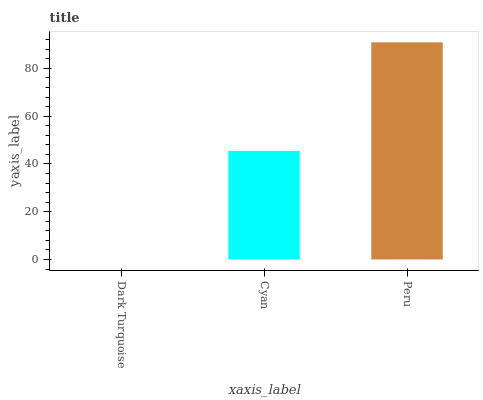Is Dark Turquoise the minimum?
Answer yes or no. Yes. Is Peru the maximum?
Answer yes or no. Yes. Is Cyan the minimum?
Answer yes or no. No. Is Cyan the maximum?
Answer yes or no. No. Is Cyan greater than Dark Turquoise?
Answer yes or no. Yes. Is Dark Turquoise less than Cyan?
Answer yes or no. Yes. Is Dark Turquoise greater than Cyan?
Answer yes or no. No. Is Cyan less than Dark Turquoise?
Answer yes or no. No. Is Cyan the high median?
Answer yes or no. Yes. Is Cyan the low median?
Answer yes or no. Yes. Is Dark Turquoise the high median?
Answer yes or no. No. Is Peru the low median?
Answer yes or no. No. 